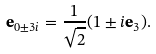Convert formula to latex. <formula><loc_0><loc_0><loc_500><loc_500>\mathbf e _ { 0 \pm 3 i } = \frac { 1 } { \sqrt { 2 } } ( 1 \pm i \mathbf e _ { 3 } ) .</formula> 